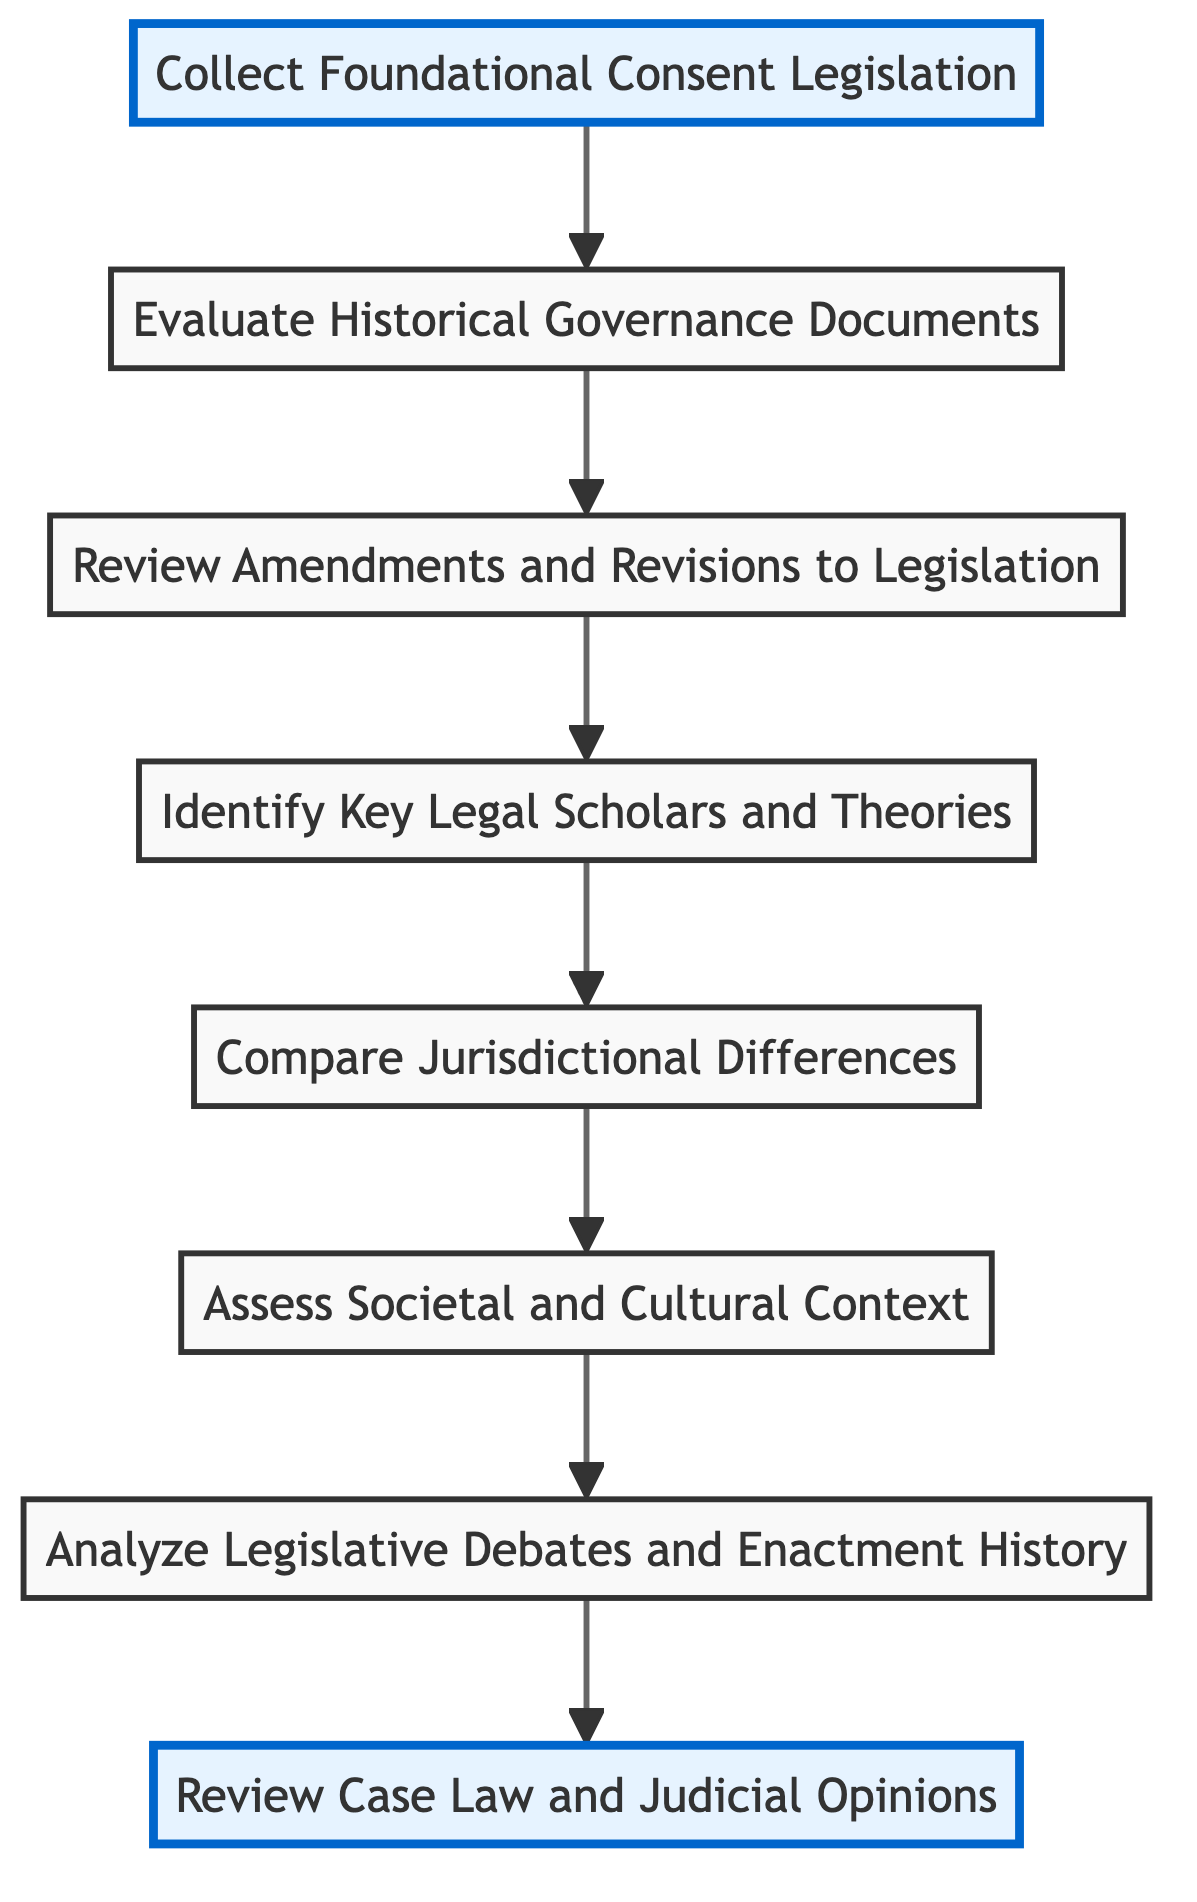What is the first step in the procedure? The diagram begins with "Collect Foundational Consent Legislation" as the first step at the bottom.
Answer: Collect Foundational Consent Legislation How many steps are there in total? There are a total of 8 steps in the flow chart, starting from "Collect Foundational Consent Legislation" to "Review Case Law and Judicial Opinions."
Answer: 8 Which element is located directly above “Assess Societal and Cultural Context”? "Compare Jurisdictional Differences" is directly above "Assess Societal and Cultural Context" as per the flow of the diagram.
Answer: Compare Jurisdictional Differences What is the last step in the analysis process? The final step in the flow chart is "Review Case Law and Judicial Opinions," which is positioned at the top of the flow diagram.
Answer: Review Case Law and Judicial Opinions Which two elements are highlighted in the diagram? The elements highlighted are "Collect Foundational Consent Legislation" and "Review Case Law and Judicial Opinions," indicating focus on the starting and final steps.
Answer: Collect Foundational Consent Legislation, Review Case Law and Judicial Opinions What is the relationship between "Analyze Legislative Debates and Enactment History" and "Assess Societal and Cultural Context"? "Analyze Legislative Debates and Enactment History" is positioned directly above "Assess Societal and Cultural Context," indicating a step that follows from it in the analysis process.
Answer: Above How does the flow from "Review Amendments and Revisions to Legislation" proceed? The flow continues upward to "Identify Key Legal Scholars and Theories," indicating a sequential process where each step builds upon the previous one.
Answer: Identify Key Legal Scholars and Theories Which element describes the investigation into debates during legislation? "Analyze Legislative Debates and Enactment History" describes the investigation into debates that occurred during the enactment of consent laws.
Answer: Analyze Legislative Debates and Enactment History 